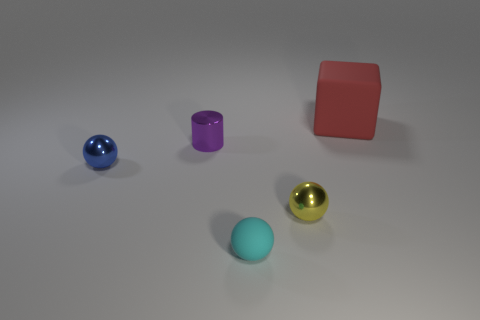What number of small things are red matte things or metallic objects?
Ensure brevity in your answer.  3. What is the blue sphere made of?
Ensure brevity in your answer.  Metal. What is the object that is in front of the large rubber thing and on the right side of the tiny cyan sphere made of?
Make the answer very short. Metal. There is a big object; is its color the same as the rubber object on the left side of the red object?
Offer a terse response. No. What is the material of the cyan object that is the same size as the purple thing?
Make the answer very short. Rubber. Are there any cyan balls that have the same material as the cylinder?
Keep it short and to the point. No. What number of purple metal things are there?
Give a very brief answer. 1. Is the material of the blue sphere the same as the tiny sphere right of the tiny matte object?
Provide a short and direct response. Yes. How many matte cubes are the same color as the shiny cylinder?
Ensure brevity in your answer.  0. How big is the cyan object?
Your answer should be compact. Small. 